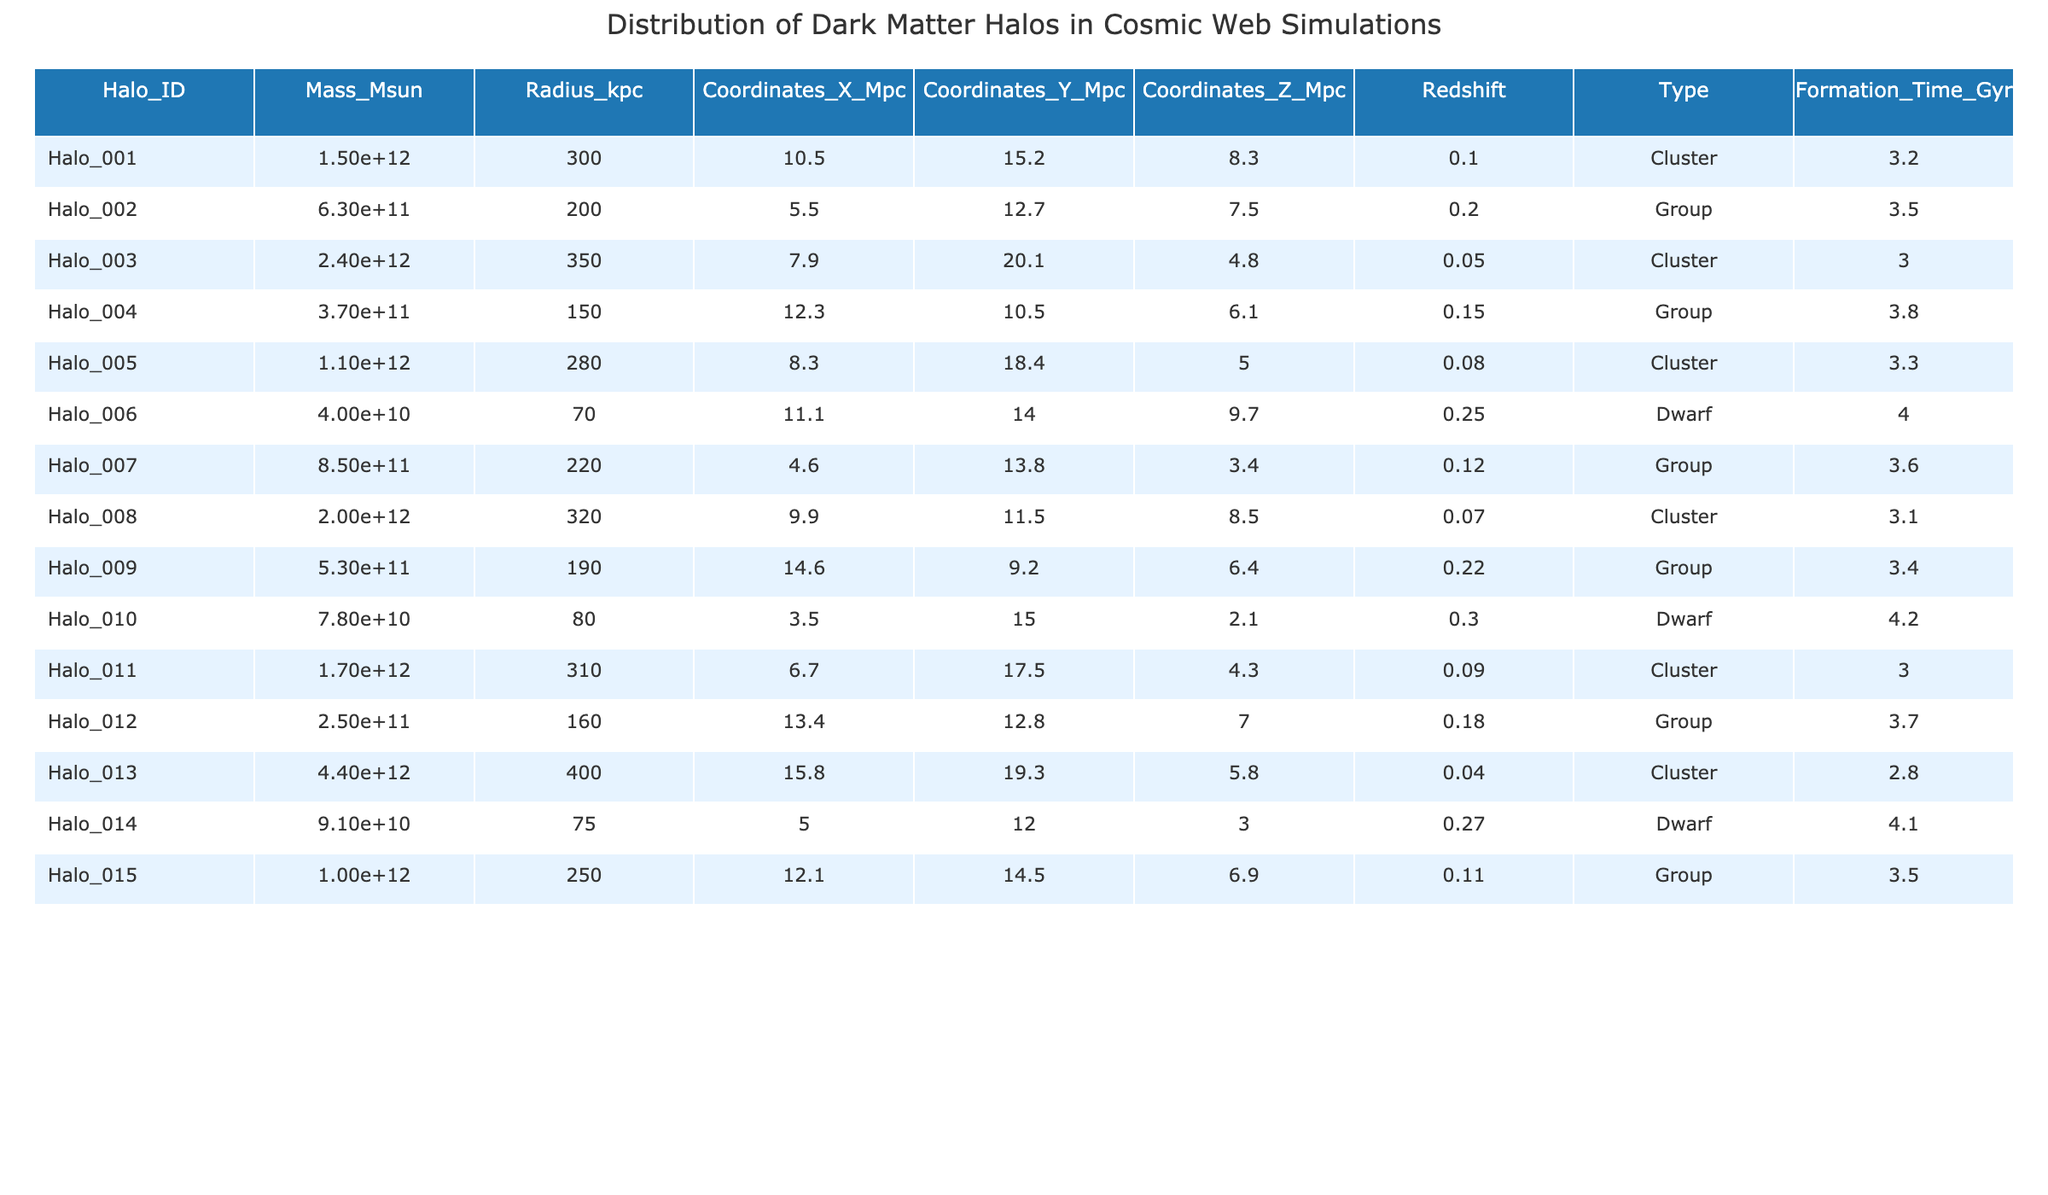What is the mass of Halo_013? From the table, the mass of Halo_013 is listed under the "Mass_Msun" column. The value shown is "4.4e12", which means 4.4 times 10 to the power of 12 solar masses.
Answer: 4.4e12 Which halo has the largest radius? By examining the "Radius_kpc" column, Halo_013 has the highest value, which is 400 kpc.
Answer: 400 kpc How many dwarf halos are there in total? Looking at the "Type" column, I can count the entries labeled "Dwarf". There are 3 entries (Halo_006, Halo_010, and Halo_014) that fit this category.
Answer: 3 What is the average formation time of all clusters? First, identify the halos classified as "Cluster": Halo_001, Halo_003, Halo_005, Halo_008, Halo_011, and Halo_013. Their formation times are 3.2, 3.0, 3.3, 3.1, 3.0, and 2.8 Gyr respectively. Adding these gives 16.4 Gyr, and dividing by 6 (the number of cluster halos) gives approximately 2.73 Gyr.
Answer: 2.73 Gyr Is there any halo with a formation time greater than 4 Gyr? Reviewing the "Formation_Time_Gyr" column, all entries are less than 4 Gyr, making the statement false.
Answer: No What halo has the highest mass-to-radius ratio? To determine this, calculate the mass-to-radius ratio (Mass_Msun / Radius_kpc) for each halo. For example, for Halo_001 it's 1.5e12 / 300, which is 5e9. After calculating for all entries, Halo_013 has the highest ratio (4.4e12 / 400), which is 11e9.
Answer: Halo_013 What are the coordinates of the halo with the smallest mass? The smallest mass is found for Halo_006, listed as 4.0e10 in the "Mass_Msun" column. Its coordinates are (11.1, 14.0, 9.7) Mpc from the respective coordinate columns.
Answer: (11.1, 14.0, 9.7) What is the difference in mass between Halo_002 and Halo_015? Using the "Mass_Msun" values: Halo_002 has 6.3e11 and Halo_015 has 1.0e12. Subtracting gives (1.0e12 - 6.3e11) = 3.7e11 solar masses.
Answer: 3.7e11 Do any halos have the same formation time? Checking the "Formation_Time_Gyr" column, I see that Halo_001 and Halo_011 both have 3.0 Gyr, indicating they share the same formation time.
Answer: Yes What is the total mass of all halos classified as "Group"? The groups are Halo_002, Halo_004, Halo_007, Halo_009, and Halo_012 with masses 6.3e11, 3.7e11, 8.5e11, 5.3e11, and 2.5e11 respectively. Adding these gives a total mass of 2.75e12 solar masses.
Answer: 2.75e12 